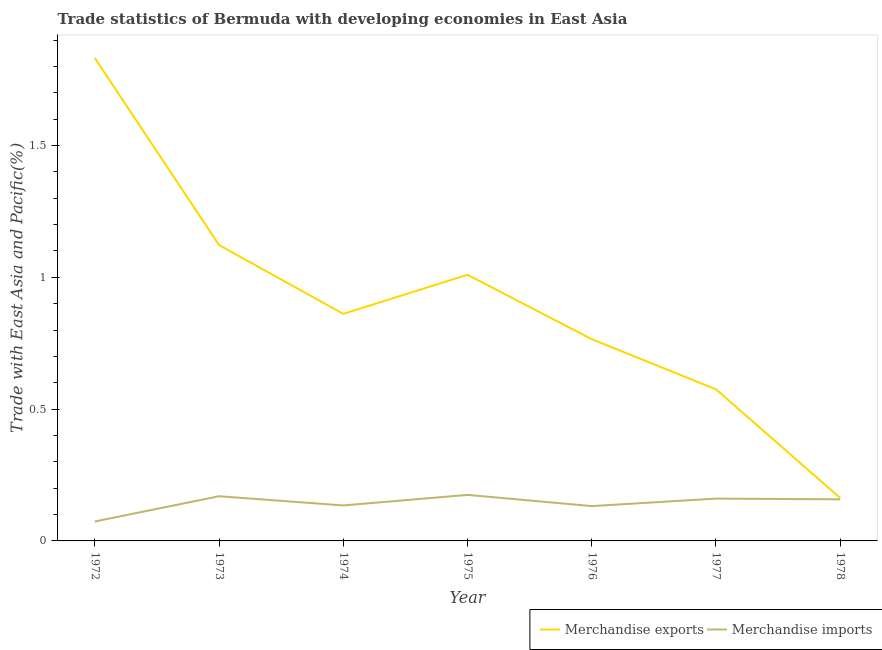How many different coloured lines are there?
Offer a terse response. 2. What is the merchandise imports in 1978?
Offer a terse response. 0.16. Across all years, what is the maximum merchandise exports?
Make the answer very short. 1.83. Across all years, what is the minimum merchandise exports?
Your response must be concise. 0.16. In which year was the merchandise exports maximum?
Provide a short and direct response. 1972. What is the total merchandise imports in the graph?
Ensure brevity in your answer.  1. What is the difference between the merchandise imports in 1976 and that in 1977?
Ensure brevity in your answer.  -0.03. What is the difference between the merchandise exports in 1973 and the merchandise imports in 1978?
Provide a succinct answer. 0.96. What is the average merchandise exports per year?
Provide a succinct answer. 0.9. In the year 1973, what is the difference between the merchandise imports and merchandise exports?
Give a very brief answer. -0.95. In how many years, is the merchandise imports greater than 0.4 %?
Provide a short and direct response. 0. What is the ratio of the merchandise imports in 1973 to that in 1977?
Offer a terse response. 1.06. Is the difference between the merchandise exports in 1972 and 1976 greater than the difference between the merchandise imports in 1972 and 1976?
Keep it short and to the point. Yes. What is the difference between the highest and the second highest merchandise imports?
Your answer should be compact. 0.01. What is the difference between the highest and the lowest merchandise imports?
Your response must be concise. 0.1. In how many years, is the merchandise imports greater than the average merchandise imports taken over all years?
Your response must be concise. 4. Is the sum of the merchandise imports in 1975 and 1977 greater than the maximum merchandise exports across all years?
Make the answer very short. No. Does the merchandise exports monotonically increase over the years?
Offer a terse response. No. Does the graph contain any zero values?
Make the answer very short. No. Where does the legend appear in the graph?
Offer a terse response. Bottom right. What is the title of the graph?
Keep it short and to the point. Trade statistics of Bermuda with developing economies in East Asia. Does "Manufacturing industries and construction" appear as one of the legend labels in the graph?
Keep it short and to the point. No. What is the label or title of the X-axis?
Your answer should be very brief. Year. What is the label or title of the Y-axis?
Your response must be concise. Trade with East Asia and Pacific(%). What is the Trade with East Asia and Pacific(%) of Merchandise exports in 1972?
Your answer should be compact. 1.83. What is the Trade with East Asia and Pacific(%) of Merchandise imports in 1972?
Your answer should be compact. 0.07. What is the Trade with East Asia and Pacific(%) of Merchandise exports in 1973?
Ensure brevity in your answer.  1.12. What is the Trade with East Asia and Pacific(%) of Merchandise imports in 1973?
Give a very brief answer. 0.17. What is the Trade with East Asia and Pacific(%) of Merchandise exports in 1974?
Offer a very short reply. 0.86. What is the Trade with East Asia and Pacific(%) in Merchandise imports in 1974?
Your response must be concise. 0.13. What is the Trade with East Asia and Pacific(%) of Merchandise exports in 1975?
Offer a very short reply. 1.01. What is the Trade with East Asia and Pacific(%) in Merchandise imports in 1975?
Offer a terse response. 0.17. What is the Trade with East Asia and Pacific(%) in Merchandise exports in 1976?
Your answer should be very brief. 0.77. What is the Trade with East Asia and Pacific(%) in Merchandise imports in 1976?
Your answer should be very brief. 0.13. What is the Trade with East Asia and Pacific(%) of Merchandise exports in 1977?
Offer a terse response. 0.58. What is the Trade with East Asia and Pacific(%) of Merchandise imports in 1977?
Provide a short and direct response. 0.16. What is the Trade with East Asia and Pacific(%) in Merchandise exports in 1978?
Offer a terse response. 0.16. What is the Trade with East Asia and Pacific(%) in Merchandise imports in 1978?
Your response must be concise. 0.16. Across all years, what is the maximum Trade with East Asia and Pacific(%) in Merchandise exports?
Offer a very short reply. 1.83. Across all years, what is the maximum Trade with East Asia and Pacific(%) in Merchandise imports?
Give a very brief answer. 0.17. Across all years, what is the minimum Trade with East Asia and Pacific(%) in Merchandise exports?
Your response must be concise. 0.16. Across all years, what is the minimum Trade with East Asia and Pacific(%) in Merchandise imports?
Give a very brief answer. 0.07. What is the total Trade with East Asia and Pacific(%) of Merchandise exports in the graph?
Your answer should be compact. 6.33. What is the difference between the Trade with East Asia and Pacific(%) of Merchandise exports in 1972 and that in 1973?
Offer a terse response. 0.71. What is the difference between the Trade with East Asia and Pacific(%) of Merchandise imports in 1972 and that in 1973?
Keep it short and to the point. -0.1. What is the difference between the Trade with East Asia and Pacific(%) of Merchandise exports in 1972 and that in 1974?
Give a very brief answer. 0.97. What is the difference between the Trade with East Asia and Pacific(%) of Merchandise imports in 1972 and that in 1974?
Give a very brief answer. -0.06. What is the difference between the Trade with East Asia and Pacific(%) in Merchandise exports in 1972 and that in 1975?
Your answer should be compact. 0.82. What is the difference between the Trade with East Asia and Pacific(%) in Merchandise imports in 1972 and that in 1975?
Ensure brevity in your answer.  -0.1. What is the difference between the Trade with East Asia and Pacific(%) in Merchandise exports in 1972 and that in 1976?
Your answer should be very brief. 1.07. What is the difference between the Trade with East Asia and Pacific(%) in Merchandise imports in 1972 and that in 1976?
Provide a succinct answer. -0.06. What is the difference between the Trade with East Asia and Pacific(%) of Merchandise exports in 1972 and that in 1977?
Ensure brevity in your answer.  1.26. What is the difference between the Trade with East Asia and Pacific(%) in Merchandise imports in 1972 and that in 1977?
Offer a terse response. -0.09. What is the difference between the Trade with East Asia and Pacific(%) in Merchandise exports in 1972 and that in 1978?
Provide a succinct answer. 1.67. What is the difference between the Trade with East Asia and Pacific(%) of Merchandise imports in 1972 and that in 1978?
Your response must be concise. -0.08. What is the difference between the Trade with East Asia and Pacific(%) of Merchandise exports in 1973 and that in 1974?
Provide a succinct answer. 0.26. What is the difference between the Trade with East Asia and Pacific(%) of Merchandise imports in 1973 and that in 1974?
Offer a very short reply. 0.03. What is the difference between the Trade with East Asia and Pacific(%) of Merchandise exports in 1973 and that in 1975?
Offer a very short reply. 0.11. What is the difference between the Trade with East Asia and Pacific(%) of Merchandise imports in 1973 and that in 1975?
Your response must be concise. -0.01. What is the difference between the Trade with East Asia and Pacific(%) of Merchandise exports in 1973 and that in 1976?
Your response must be concise. 0.36. What is the difference between the Trade with East Asia and Pacific(%) in Merchandise imports in 1973 and that in 1976?
Provide a succinct answer. 0.04. What is the difference between the Trade with East Asia and Pacific(%) of Merchandise exports in 1973 and that in 1977?
Ensure brevity in your answer.  0.55. What is the difference between the Trade with East Asia and Pacific(%) of Merchandise imports in 1973 and that in 1977?
Your answer should be compact. 0.01. What is the difference between the Trade with East Asia and Pacific(%) in Merchandise exports in 1973 and that in 1978?
Offer a very short reply. 0.96. What is the difference between the Trade with East Asia and Pacific(%) of Merchandise imports in 1973 and that in 1978?
Make the answer very short. 0.01. What is the difference between the Trade with East Asia and Pacific(%) in Merchandise exports in 1974 and that in 1975?
Make the answer very short. -0.15. What is the difference between the Trade with East Asia and Pacific(%) in Merchandise imports in 1974 and that in 1975?
Your answer should be very brief. -0.04. What is the difference between the Trade with East Asia and Pacific(%) of Merchandise exports in 1974 and that in 1976?
Your answer should be very brief. 0.1. What is the difference between the Trade with East Asia and Pacific(%) in Merchandise imports in 1974 and that in 1976?
Keep it short and to the point. 0. What is the difference between the Trade with East Asia and Pacific(%) of Merchandise exports in 1974 and that in 1977?
Offer a terse response. 0.29. What is the difference between the Trade with East Asia and Pacific(%) of Merchandise imports in 1974 and that in 1977?
Provide a succinct answer. -0.03. What is the difference between the Trade with East Asia and Pacific(%) in Merchandise exports in 1974 and that in 1978?
Provide a succinct answer. 0.7. What is the difference between the Trade with East Asia and Pacific(%) in Merchandise imports in 1974 and that in 1978?
Your response must be concise. -0.02. What is the difference between the Trade with East Asia and Pacific(%) in Merchandise exports in 1975 and that in 1976?
Provide a short and direct response. 0.24. What is the difference between the Trade with East Asia and Pacific(%) in Merchandise imports in 1975 and that in 1976?
Your response must be concise. 0.04. What is the difference between the Trade with East Asia and Pacific(%) in Merchandise exports in 1975 and that in 1977?
Offer a very short reply. 0.43. What is the difference between the Trade with East Asia and Pacific(%) in Merchandise imports in 1975 and that in 1977?
Your answer should be compact. 0.01. What is the difference between the Trade with East Asia and Pacific(%) in Merchandise exports in 1975 and that in 1978?
Ensure brevity in your answer.  0.85. What is the difference between the Trade with East Asia and Pacific(%) of Merchandise imports in 1975 and that in 1978?
Offer a terse response. 0.02. What is the difference between the Trade with East Asia and Pacific(%) in Merchandise exports in 1976 and that in 1977?
Your answer should be compact. 0.19. What is the difference between the Trade with East Asia and Pacific(%) in Merchandise imports in 1976 and that in 1977?
Offer a very short reply. -0.03. What is the difference between the Trade with East Asia and Pacific(%) of Merchandise exports in 1976 and that in 1978?
Provide a short and direct response. 0.6. What is the difference between the Trade with East Asia and Pacific(%) of Merchandise imports in 1976 and that in 1978?
Offer a terse response. -0.03. What is the difference between the Trade with East Asia and Pacific(%) in Merchandise exports in 1977 and that in 1978?
Offer a terse response. 0.41. What is the difference between the Trade with East Asia and Pacific(%) in Merchandise imports in 1977 and that in 1978?
Your answer should be compact. 0. What is the difference between the Trade with East Asia and Pacific(%) in Merchandise exports in 1972 and the Trade with East Asia and Pacific(%) in Merchandise imports in 1973?
Provide a short and direct response. 1.66. What is the difference between the Trade with East Asia and Pacific(%) in Merchandise exports in 1972 and the Trade with East Asia and Pacific(%) in Merchandise imports in 1974?
Your answer should be compact. 1.7. What is the difference between the Trade with East Asia and Pacific(%) in Merchandise exports in 1972 and the Trade with East Asia and Pacific(%) in Merchandise imports in 1975?
Offer a very short reply. 1.66. What is the difference between the Trade with East Asia and Pacific(%) of Merchandise exports in 1972 and the Trade with East Asia and Pacific(%) of Merchandise imports in 1976?
Provide a succinct answer. 1.7. What is the difference between the Trade with East Asia and Pacific(%) of Merchandise exports in 1972 and the Trade with East Asia and Pacific(%) of Merchandise imports in 1977?
Keep it short and to the point. 1.67. What is the difference between the Trade with East Asia and Pacific(%) in Merchandise exports in 1972 and the Trade with East Asia and Pacific(%) in Merchandise imports in 1978?
Your answer should be very brief. 1.67. What is the difference between the Trade with East Asia and Pacific(%) in Merchandise exports in 1973 and the Trade with East Asia and Pacific(%) in Merchandise imports in 1974?
Keep it short and to the point. 0.99. What is the difference between the Trade with East Asia and Pacific(%) of Merchandise exports in 1973 and the Trade with East Asia and Pacific(%) of Merchandise imports in 1975?
Keep it short and to the point. 0.95. What is the difference between the Trade with East Asia and Pacific(%) in Merchandise exports in 1973 and the Trade with East Asia and Pacific(%) in Merchandise imports in 1976?
Make the answer very short. 0.99. What is the difference between the Trade with East Asia and Pacific(%) in Merchandise exports in 1973 and the Trade with East Asia and Pacific(%) in Merchandise imports in 1977?
Provide a succinct answer. 0.96. What is the difference between the Trade with East Asia and Pacific(%) of Merchandise exports in 1973 and the Trade with East Asia and Pacific(%) of Merchandise imports in 1978?
Provide a succinct answer. 0.96. What is the difference between the Trade with East Asia and Pacific(%) of Merchandise exports in 1974 and the Trade with East Asia and Pacific(%) of Merchandise imports in 1975?
Your response must be concise. 0.69. What is the difference between the Trade with East Asia and Pacific(%) in Merchandise exports in 1974 and the Trade with East Asia and Pacific(%) in Merchandise imports in 1976?
Your response must be concise. 0.73. What is the difference between the Trade with East Asia and Pacific(%) of Merchandise exports in 1974 and the Trade with East Asia and Pacific(%) of Merchandise imports in 1977?
Your answer should be compact. 0.7. What is the difference between the Trade with East Asia and Pacific(%) in Merchandise exports in 1974 and the Trade with East Asia and Pacific(%) in Merchandise imports in 1978?
Ensure brevity in your answer.  0.7. What is the difference between the Trade with East Asia and Pacific(%) of Merchandise exports in 1975 and the Trade with East Asia and Pacific(%) of Merchandise imports in 1976?
Make the answer very short. 0.88. What is the difference between the Trade with East Asia and Pacific(%) of Merchandise exports in 1975 and the Trade with East Asia and Pacific(%) of Merchandise imports in 1977?
Your answer should be very brief. 0.85. What is the difference between the Trade with East Asia and Pacific(%) of Merchandise exports in 1975 and the Trade with East Asia and Pacific(%) of Merchandise imports in 1978?
Offer a very short reply. 0.85. What is the difference between the Trade with East Asia and Pacific(%) in Merchandise exports in 1976 and the Trade with East Asia and Pacific(%) in Merchandise imports in 1977?
Provide a short and direct response. 0.6. What is the difference between the Trade with East Asia and Pacific(%) of Merchandise exports in 1976 and the Trade with East Asia and Pacific(%) of Merchandise imports in 1978?
Keep it short and to the point. 0.61. What is the difference between the Trade with East Asia and Pacific(%) in Merchandise exports in 1977 and the Trade with East Asia and Pacific(%) in Merchandise imports in 1978?
Offer a very short reply. 0.42. What is the average Trade with East Asia and Pacific(%) in Merchandise exports per year?
Your answer should be very brief. 0.9. What is the average Trade with East Asia and Pacific(%) in Merchandise imports per year?
Offer a terse response. 0.14. In the year 1972, what is the difference between the Trade with East Asia and Pacific(%) in Merchandise exports and Trade with East Asia and Pacific(%) in Merchandise imports?
Make the answer very short. 1.76. In the year 1973, what is the difference between the Trade with East Asia and Pacific(%) in Merchandise exports and Trade with East Asia and Pacific(%) in Merchandise imports?
Provide a succinct answer. 0.95. In the year 1974, what is the difference between the Trade with East Asia and Pacific(%) of Merchandise exports and Trade with East Asia and Pacific(%) of Merchandise imports?
Your answer should be compact. 0.73. In the year 1975, what is the difference between the Trade with East Asia and Pacific(%) of Merchandise exports and Trade with East Asia and Pacific(%) of Merchandise imports?
Your response must be concise. 0.83. In the year 1976, what is the difference between the Trade with East Asia and Pacific(%) in Merchandise exports and Trade with East Asia and Pacific(%) in Merchandise imports?
Provide a short and direct response. 0.63. In the year 1977, what is the difference between the Trade with East Asia and Pacific(%) in Merchandise exports and Trade with East Asia and Pacific(%) in Merchandise imports?
Keep it short and to the point. 0.41. In the year 1978, what is the difference between the Trade with East Asia and Pacific(%) in Merchandise exports and Trade with East Asia and Pacific(%) in Merchandise imports?
Ensure brevity in your answer.  0. What is the ratio of the Trade with East Asia and Pacific(%) of Merchandise exports in 1972 to that in 1973?
Your answer should be compact. 1.63. What is the ratio of the Trade with East Asia and Pacific(%) in Merchandise imports in 1972 to that in 1973?
Ensure brevity in your answer.  0.44. What is the ratio of the Trade with East Asia and Pacific(%) in Merchandise exports in 1972 to that in 1974?
Give a very brief answer. 2.13. What is the ratio of the Trade with East Asia and Pacific(%) in Merchandise imports in 1972 to that in 1974?
Make the answer very short. 0.55. What is the ratio of the Trade with East Asia and Pacific(%) of Merchandise exports in 1972 to that in 1975?
Make the answer very short. 1.81. What is the ratio of the Trade with East Asia and Pacific(%) of Merchandise imports in 1972 to that in 1975?
Offer a terse response. 0.42. What is the ratio of the Trade with East Asia and Pacific(%) of Merchandise exports in 1972 to that in 1976?
Ensure brevity in your answer.  2.39. What is the ratio of the Trade with East Asia and Pacific(%) in Merchandise imports in 1972 to that in 1976?
Your answer should be compact. 0.56. What is the ratio of the Trade with East Asia and Pacific(%) in Merchandise exports in 1972 to that in 1977?
Your response must be concise. 3.19. What is the ratio of the Trade with East Asia and Pacific(%) in Merchandise imports in 1972 to that in 1977?
Offer a very short reply. 0.46. What is the ratio of the Trade with East Asia and Pacific(%) in Merchandise exports in 1972 to that in 1978?
Your response must be concise. 11.26. What is the ratio of the Trade with East Asia and Pacific(%) in Merchandise imports in 1972 to that in 1978?
Offer a very short reply. 0.47. What is the ratio of the Trade with East Asia and Pacific(%) of Merchandise exports in 1973 to that in 1974?
Offer a very short reply. 1.3. What is the ratio of the Trade with East Asia and Pacific(%) in Merchandise imports in 1973 to that in 1974?
Your answer should be compact. 1.26. What is the ratio of the Trade with East Asia and Pacific(%) of Merchandise exports in 1973 to that in 1975?
Give a very brief answer. 1.11. What is the ratio of the Trade with East Asia and Pacific(%) of Merchandise imports in 1973 to that in 1975?
Give a very brief answer. 0.97. What is the ratio of the Trade with East Asia and Pacific(%) in Merchandise exports in 1973 to that in 1976?
Offer a very short reply. 1.47. What is the ratio of the Trade with East Asia and Pacific(%) of Merchandise imports in 1973 to that in 1976?
Offer a terse response. 1.28. What is the ratio of the Trade with East Asia and Pacific(%) in Merchandise exports in 1973 to that in 1977?
Make the answer very short. 1.95. What is the ratio of the Trade with East Asia and Pacific(%) in Merchandise imports in 1973 to that in 1977?
Ensure brevity in your answer.  1.06. What is the ratio of the Trade with East Asia and Pacific(%) in Merchandise exports in 1973 to that in 1978?
Your answer should be very brief. 6.9. What is the ratio of the Trade with East Asia and Pacific(%) of Merchandise imports in 1973 to that in 1978?
Give a very brief answer. 1.07. What is the ratio of the Trade with East Asia and Pacific(%) of Merchandise exports in 1974 to that in 1975?
Provide a short and direct response. 0.85. What is the ratio of the Trade with East Asia and Pacific(%) of Merchandise imports in 1974 to that in 1975?
Offer a very short reply. 0.77. What is the ratio of the Trade with East Asia and Pacific(%) in Merchandise exports in 1974 to that in 1976?
Ensure brevity in your answer.  1.13. What is the ratio of the Trade with East Asia and Pacific(%) in Merchandise imports in 1974 to that in 1976?
Your answer should be very brief. 1.02. What is the ratio of the Trade with East Asia and Pacific(%) in Merchandise exports in 1974 to that in 1977?
Provide a succinct answer. 1.5. What is the ratio of the Trade with East Asia and Pacific(%) of Merchandise imports in 1974 to that in 1977?
Your response must be concise. 0.84. What is the ratio of the Trade with East Asia and Pacific(%) in Merchandise exports in 1974 to that in 1978?
Keep it short and to the point. 5.29. What is the ratio of the Trade with East Asia and Pacific(%) of Merchandise imports in 1974 to that in 1978?
Provide a short and direct response. 0.85. What is the ratio of the Trade with East Asia and Pacific(%) of Merchandise exports in 1975 to that in 1976?
Give a very brief answer. 1.32. What is the ratio of the Trade with East Asia and Pacific(%) of Merchandise imports in 1975 to that in 1976?
Ensure brevity in your answer.  1.32. What is the ratio of the Trade with East Asia and Pacific(%) in Merchandise exports in 1975 to that in 1977?
Make the answer very short. 1.76. What is the ratio of the Trade with East Asia and Pacific(%) of Merchandise imports in 1975 to that in 1977?
Give a very brief answer. 1.09. What is the ratio of the Trade with East Asia and Pacific(%) of Merchandise exports in 1975 to that in 1978?
Provide a succinct answer. 6.2. What is the ratio of the Trade with East Asia and Pacific(%) of Merchandise imports in 1975 to that in 1978?
Your answer should be compact. 1.11. What is the ratio of the Trade with East Asia and Pacific(%) in Merchandise exports in 1976 to that in 1977?
Ensure brevity in your answer.  1.33. What is the ratio of the Trade with East Asia and Pacific(%) of Merchandise imports in 1976 to that in 1977?
Provide a succinct answer. 0.82. What is the ratio of the Trade with East Asia and Pacific(%) in Merchandise exports in 1976 to that in 1978?
Your answer should be compact. 4.7. What is the ratio of the Trade with East Asia and Pacific(%) of Merchandise imports in 1976 to that in 1978?
Make the answer very short. 0.84. What is the ratio of the Trade with East Asia and Pacific(%) of Merchandise exports in 1977 to that in 1978?
Provide a short and direct response. 3.53. What is the ratio of the Trade with East Asia and Pacific(%) in Merchandise imports in 1977 to that in 1978?
Ensure brevity in your answer.  1.02. What is the difference between the highest and the second highest Trade with East Asia and Pacific(%) in Merchandise exports?
Provide a succinct answer. 0.71. What is the difference between the highest and the second highest Trade with East Asia and Pacific(%) in Merchandise imports?
Keep it short and to the point. 0.01. What is the difference between the highest and the lowest Trade with East Asia and Pacific(%) in Merchandise exports?
Make the answer very short. 1.67. What is the difference between the highest and the lowest Trade with East Asia and Pacific(%) of Merchandise imports?
Give a very brief answer. 0.1. 